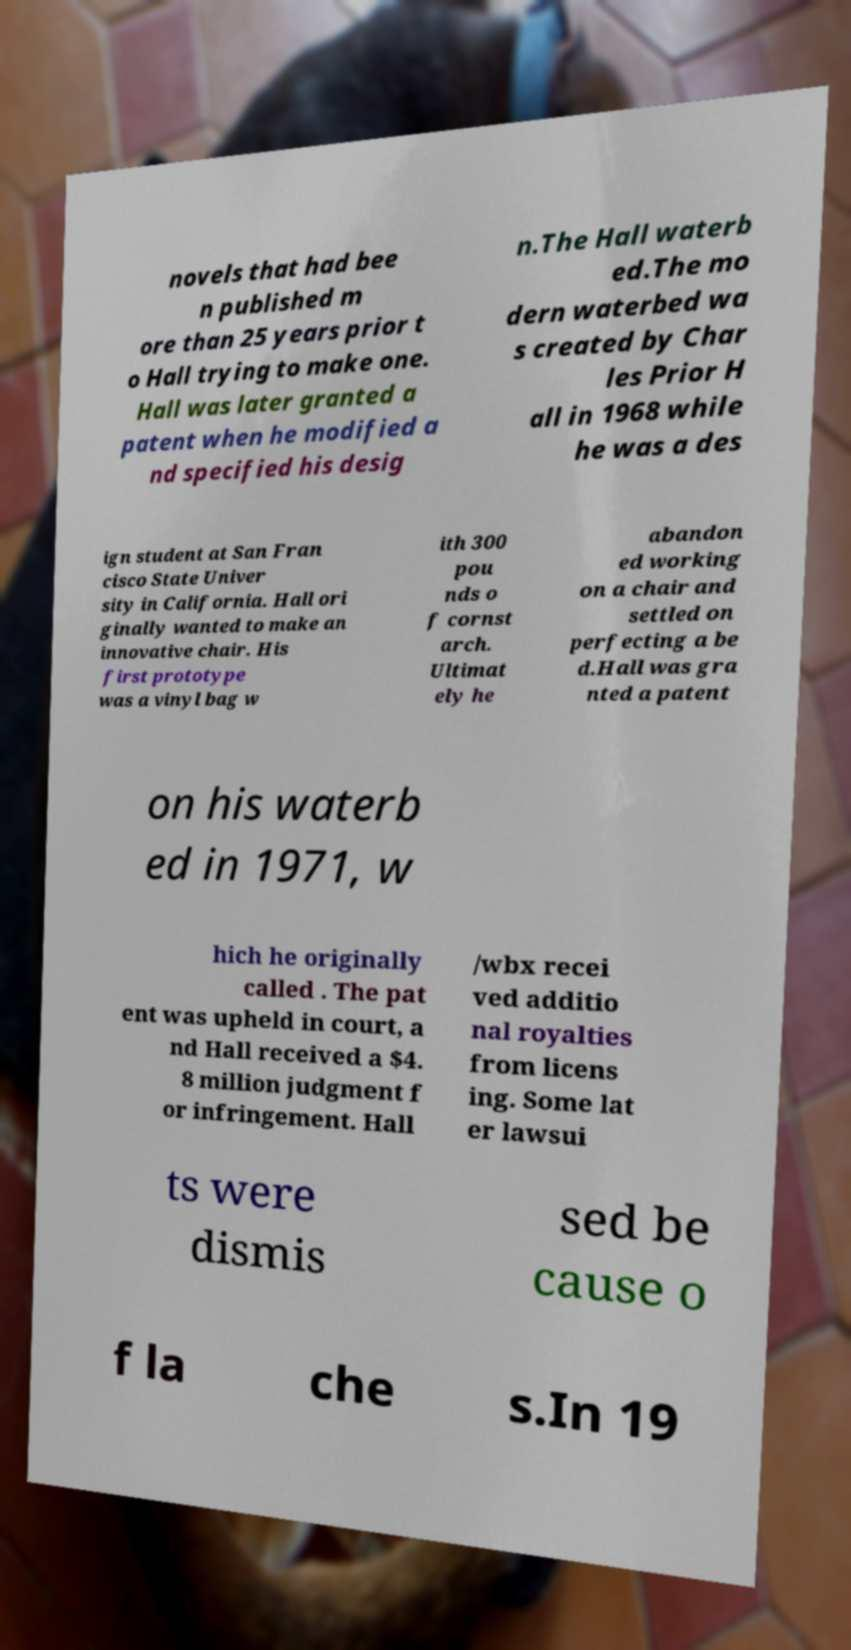Could you assist in decoding the text presented in this image and type it out clearly? novels that had bee n published m ore than 25 years prior t o Hall trying to make one. Hall was later granted a patent when he modified a nd specified his desig n.The Hall waterb ed.The mo dern waterbed wa s created by Char les Prior H all in 1968 while he was a des ign student at San Fran cisco State Univer sity in California. Hall ori ginally wanted to make an innovative chair. His first prototype was a vinyl bag w ith 300 pou nds o f cornst arch. Ultimat ely he abandon ed working on a chair and settled on perfecting a be d.Hall was gra nted a patent on his waterb ed in 1971, w hich he originally called . The pat ent was upheld in court, a nd Hall received a $4. 8 million judgment f or infringement. Hall /wbx recei ved additio nal royalties from licens ing. Some lat er lawsui ts were dismis sed be cause o f la che s.In 19 